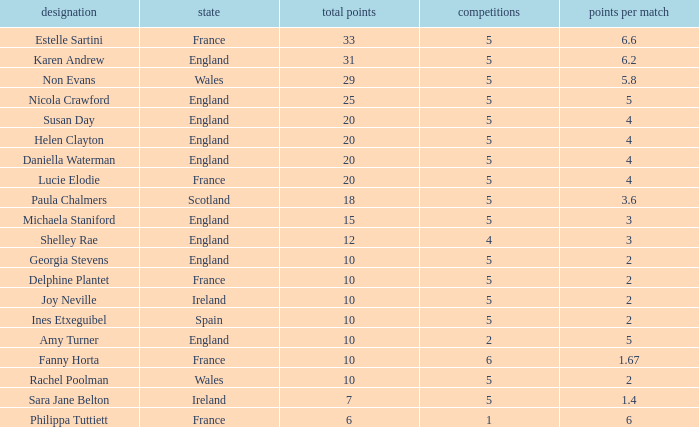Can you tell me the lowest Pts/game that has the Name of philippa tuttiett, and the Points larger then 6? None. 